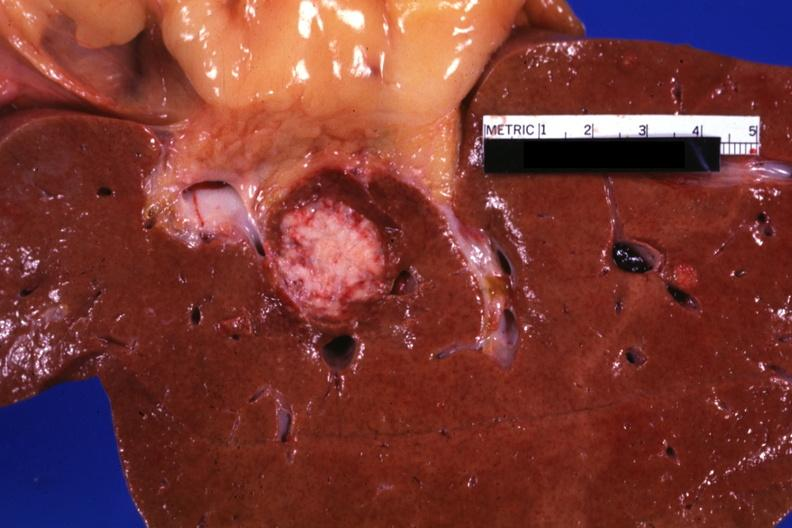s cryptosporidia present?
Answer the question using a single word or phrase. No 